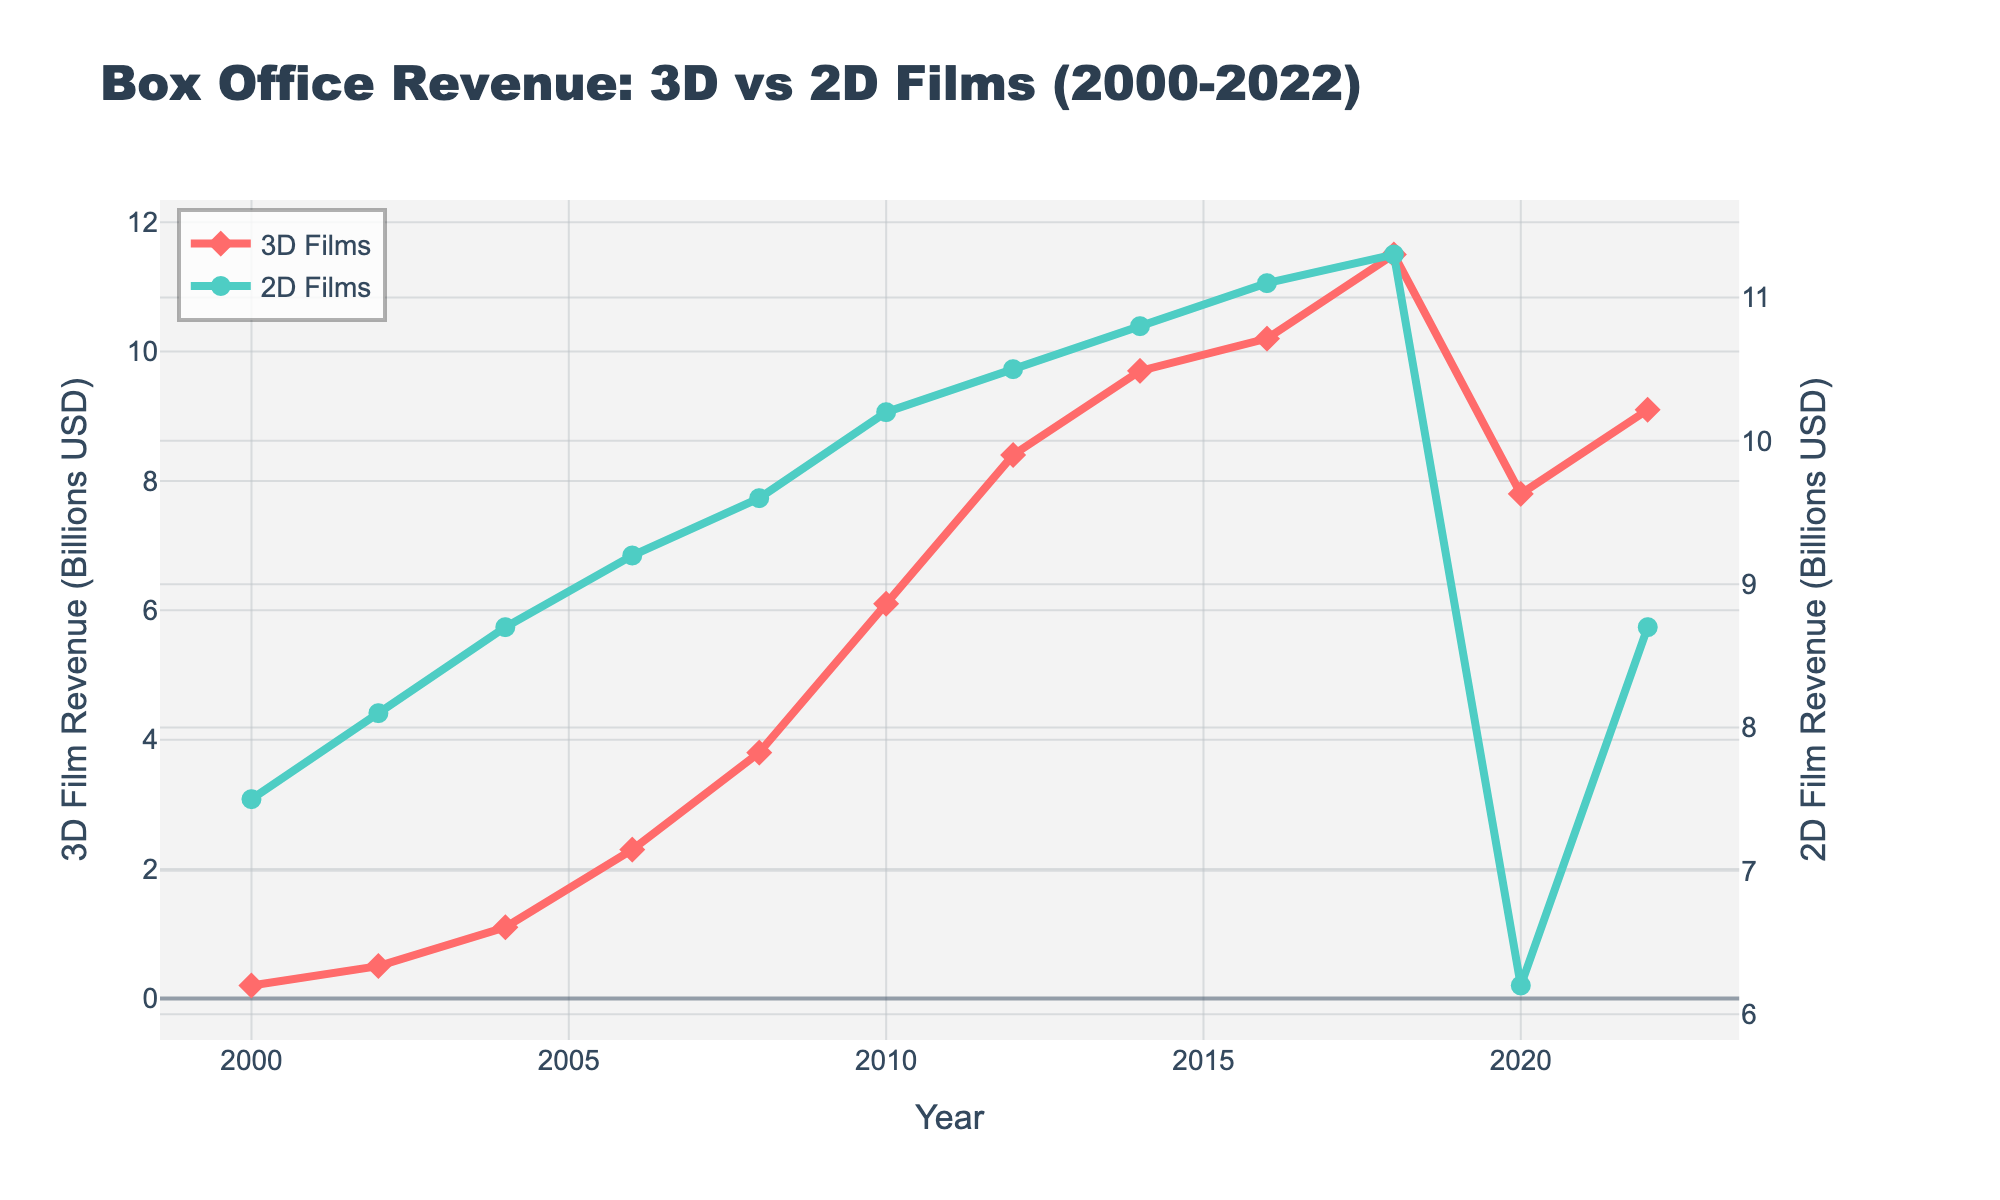What's the trend in 3D film revenues from 2000 to 2022? The 3D film revenue shows a general increasing trend from 2000 to 2022, with some fluctuations. It starts at 0.2 billion USD in 2000, peaks at 11.5 billion USD in 2018, drops to 7.8 billion USD in 2020, and partially recovers to 9.1 billion USD in 2022.
Answer: Increasing with fluctuations How do the revenues of 3D films in 2020 compare to those in 2018? The 3D film revenue in 2020 (7.8 billion USD) is lower than the 3D film revenue in 2018 (11.5 billion USD).
Answer: Lower Which year shows the highest revenue for 2D films and what is the value? The highest revenue for 2D films was in 2018, with a value of 11.3 billion USD.
Answer: 2018, 11.3 billion USD How much did the 3D film revenue grow between 2000 and 2018? The 3D film revenue in 2000 was 0.2 billion USD and it grew to 11.5 billion USD in 2018. The growth is calculated as 11.5 - 0.2 = 11.3 billion USD.
Answer: 11.3 billion USD What was the difference in revenue between 2D and 3D films in 2020? In 2020, the revenue for 2D films was 6.2 billion USD, and for 3D films, it was 7.8 billion USD. The difference is 7.8 - 6.2 = 1.6 billion USD.
Answer: 1.6 billion USD Do both 3D and 2D films show a revenue decline in 2020 compared to 2018? Yes, both 3D and 2D films show a revenue decline in 2020 compared to 2018. 3D film revenue decreased from 11.5 billion USD in 2018 to 7.8 billion USD in 2020, and 2D film revenue decreased from 11.3 billion USD in 2018 to 6.2 billion USD in 2020.
Answer: Yes What is the average revenue of 2D films over the two decades? Add all the 2D film revenue values from 2000 to 2022 and divide by the number of years. The total revenue is 7.5 + 8.1 + 8.7 + 9.2 + 9.6 + 10.2 + 10.5 + 10.8 + 11.1 + 11.3 + 6.2 + 8.7 = 111.9 billion USD. There are 12 data points, so the average is 111.9 / 12 = 9.325 billion USD.
Answer: 9.325 billion USD Between 2000 and 2022, during which time period did 3D film revenues see the most significant growth? Examine the intervals between the years. The most significant growth in 3D film revenues appears between 2008 and 2010, where the revenue jumps from 3.8 billion USD to 6.1 billion USD. The growth is 6.1 - 3.8 = 2.3 billion USD.
Answer: 2008-2010 What was the revenue of 3D films in 2016 and how does it compare to the revenue in 2022? The revenue of 3D films in 2016 was 10.2 billion USD. In 2022, the revenue is 9.1 billion USD. Therefore, the revenue in 2022 is less than in 2016.
Answer: Less How does the growth rate of 3D film revenue from 2000 to 2022 compare to that of 2D film revenue? Calculate the growth rates. For 3D films: (9.1 - 0.2) / 0.2 = 44.5 (4450%). For 2D films: (8.7 - 7.5) / 7.5 = 0.16 (16%). 3D film revenue's growth rate is significantly higher than that of 2D films.
Answer: 3D films have a significantly higher growth rate 